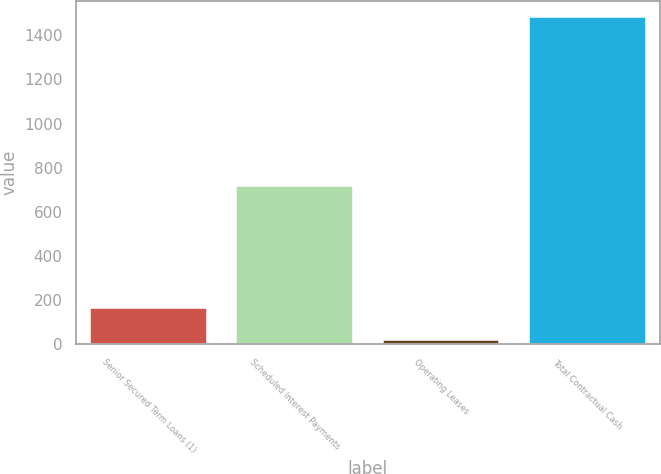Convert chart to OTSL. <chart><loc_0><loc_0><loc_500><loc_500><bar_chart><fcel>Senior Secured Term Loans (1)<fcel>Scheduled Interest Payments<fcel>Operating Leases<fcel>Total Contractual Cash<nl><fcel>165.67<fcel>715.5<fcel>19.3<fcel>1483<nl></chart> 